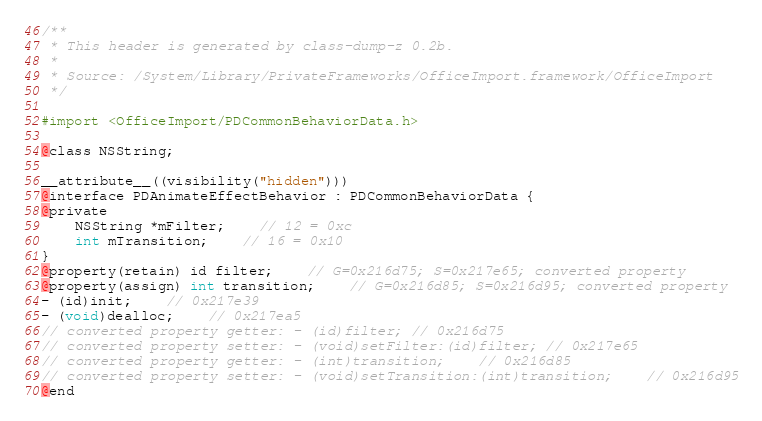<code> <loc_0><loc_0><loc_500><loc_500><_C_>/**
 * This header is generated by class-dump-z 0.2b.
 *
 * Source: /System/Library/PrivateFrameworks/OfficeImport.framework/OfficeImport
 */

#import <OfficeImport/PDCommonBehaviorData.h>

@class NSString;

__attribute__((visibility("hidden")))
@interface PDAnimateEffectBehavior : PDCommonBehaviorData {
@private
	NSString *mFilter;	// 12 = 0xc
	int mTransition;	// 16 = 0x10
}
@property(retain) id filter;	// G=0x216d75; S=0x217e65; converted property
@property(assign) int transition;	// G=0x216d85; S=0x216d95; converted property
- (id)init;	// 0x217e39
- (void)dealloc;	// 0x217ea5
// converted property getter: - (id)filter;	// 0x216d75
// converted property setter: - (void)setFilter:(id)filter;	// 0x217e65
// converted property getter: - (int)transition;	// 0x216d85
// converted property setter: - (void)setTransition:(int)transition;	// 0x216d95
@end
</code> 